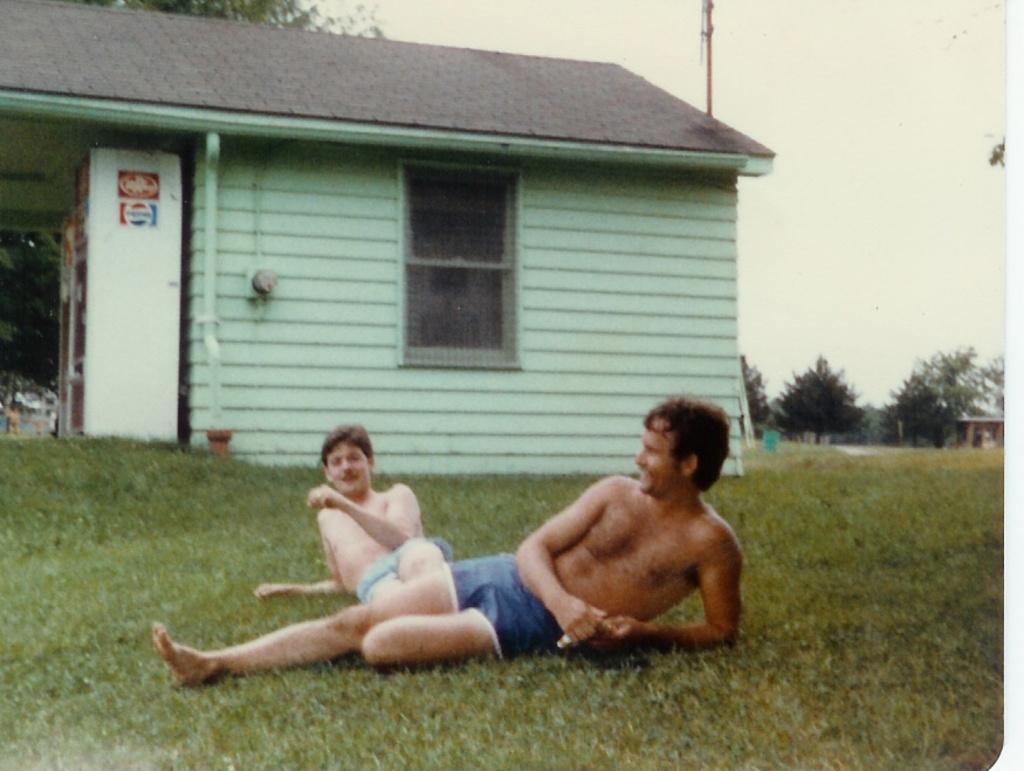How many people are in the image? There are two persons in the image. What are the persons wearing that is visible in the image? The persons are wearing blue color inner ear. What is the position of the persons in the image? The persons are laying on the grass. What can be seen in the background of the image? There is a house, pipes, trees, a pole, and the sky visible in the background of the image. What is the value of the van parked next to the house in the image? There is no van present in the image; only a house, pipes, trees, a pole, and the sky are visible in the background. How many groups of people are in the image? There is only one group of people in the image, which consists of the two persons laying on the grass. 